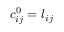<formula> <loc_0><loc_0><loc_500><loc_500>c _ { i j } ^ { 0 } = l _ { i j }</formula> 